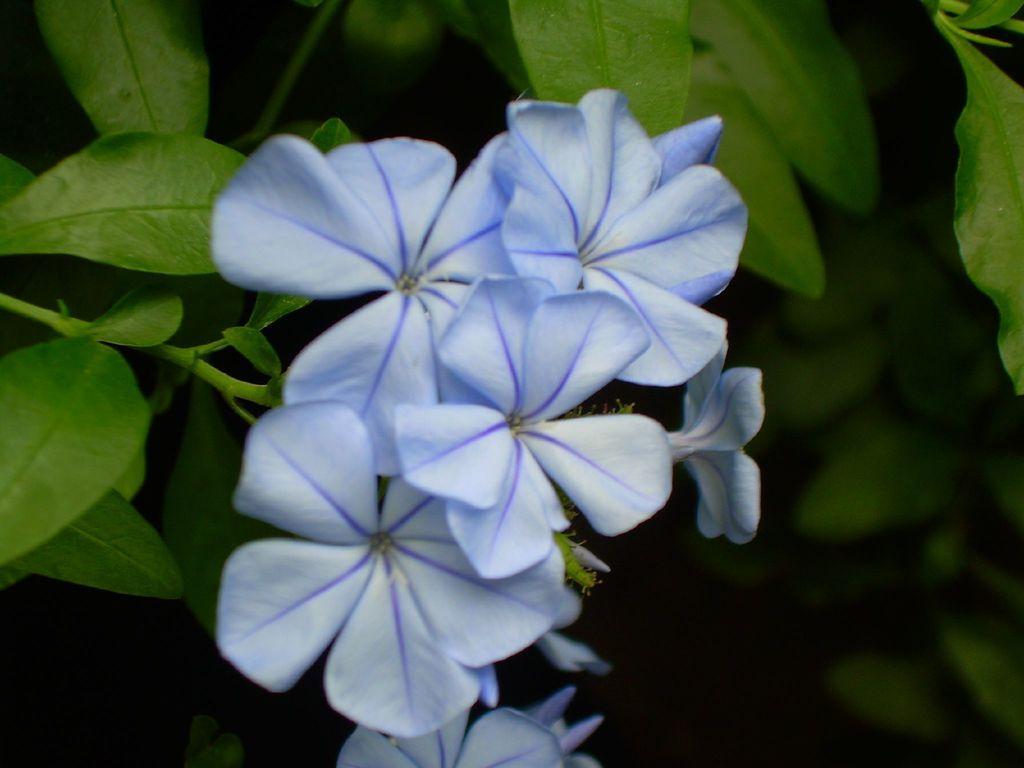Could you give a brief overview of what you see in this image? In the foreground of the picture there are flowers, leaves and stems of a plant. The background is dark. In the background there is greenery. 